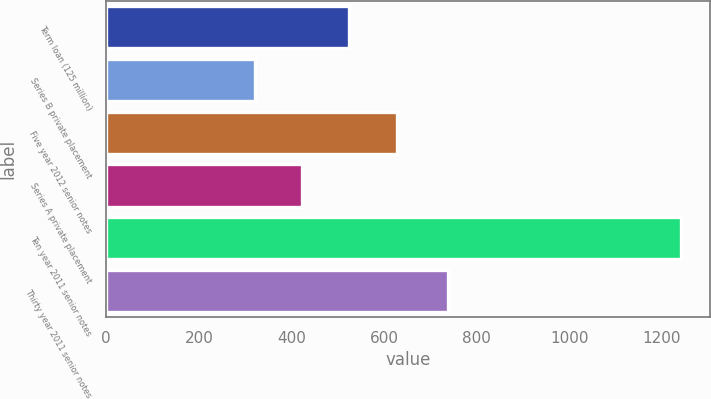Convert chart to OTSL. <chart><loc_0><loc_0><loc_500><loc_500><bar_chart><fcel>Term loan (125 million)<fcel>Series B private placement<fcel>Five year 2012 senior notes<fcel>Series A private placement<fcel>Ten year 2011 senior notes<fcel>Thirty year 2011 senior notes<nl><fcel>525.2<fcel>320.2<fcel>627.7<fcel>422.7<fcel>1242.7<fcel>737.8<nl></chart> 